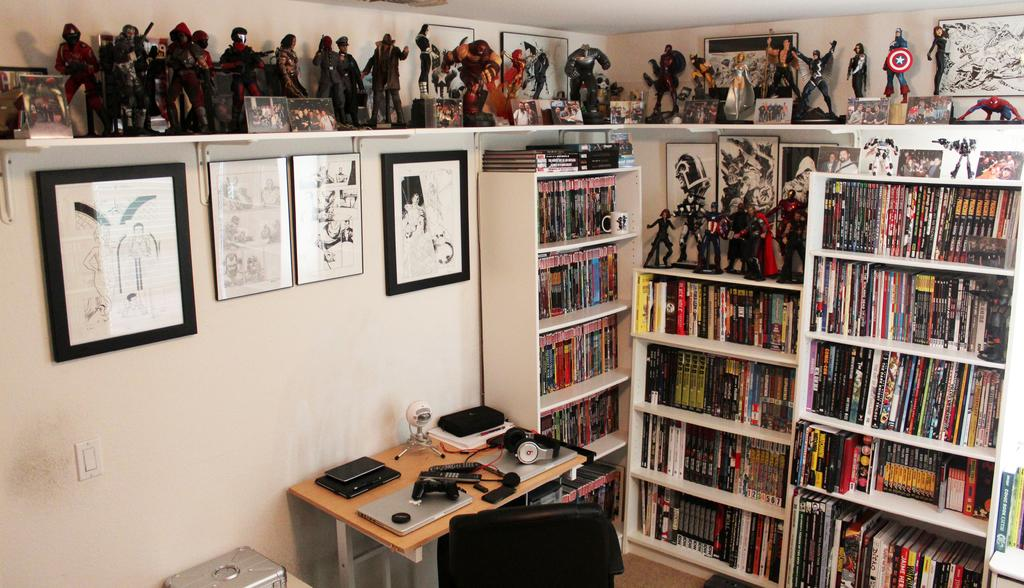What type of furniture is present in the room for storing items? The room contains bookshelves for storing items. What type of items can be found in the room for children to play with? The room contains toys for children to play with. What is displayed on the wall in the room? There are photo frames on the wall. What type of furniture is present in the room for working or eating? There is a table in the room for working or eating. What type of furniture is present in the room for sitting? There is a chair in the room for sitting. What type of electronic device is present on the table in the room? A laptop is present on the table. What type of accessory is present on the table in the room? Headphones are on the table. What type of item is present on the table in the room for reading? There is a book on the table for reading. What type of device is present on the table in the room for capturing images? A camera is on the table. What type of items can be found in the bookshelves in the room? There are books in the bookshelves. What type of meat is present on the table in the room? There is no meat present on the table in the room. What type of ring is displayed on the wall in the room? There is no ring displayed on the wall in the room. What type of gardening tool is present on the table in the room? There is no gardening tool present on the table in the room. 